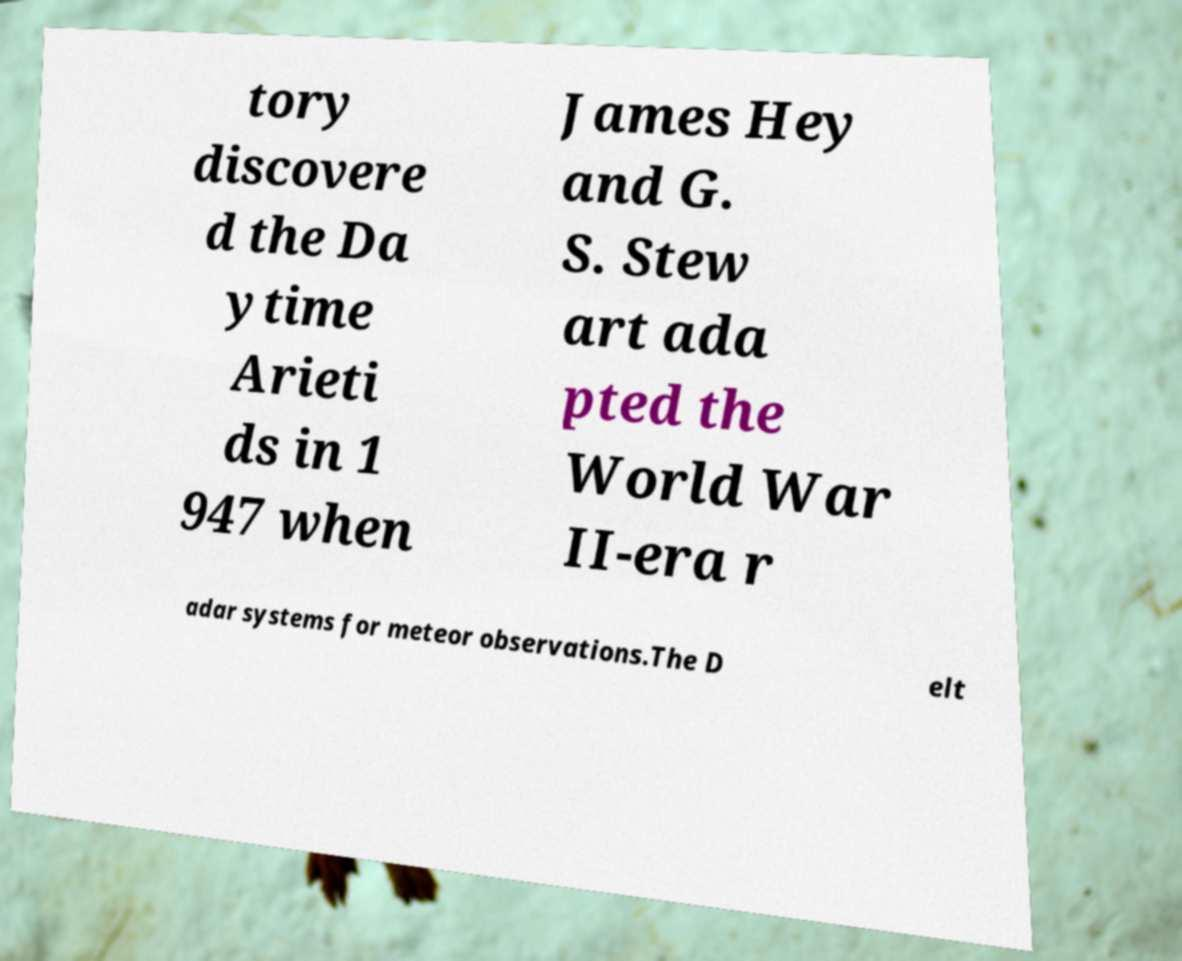Please identify and transcribe the text found in this image. tory discovere d the Da ytime Arieti ds in 1 947 when James Hey and G. S. Stew art ada pted the World War II-era r adar systems for meteor observations.The D elt 